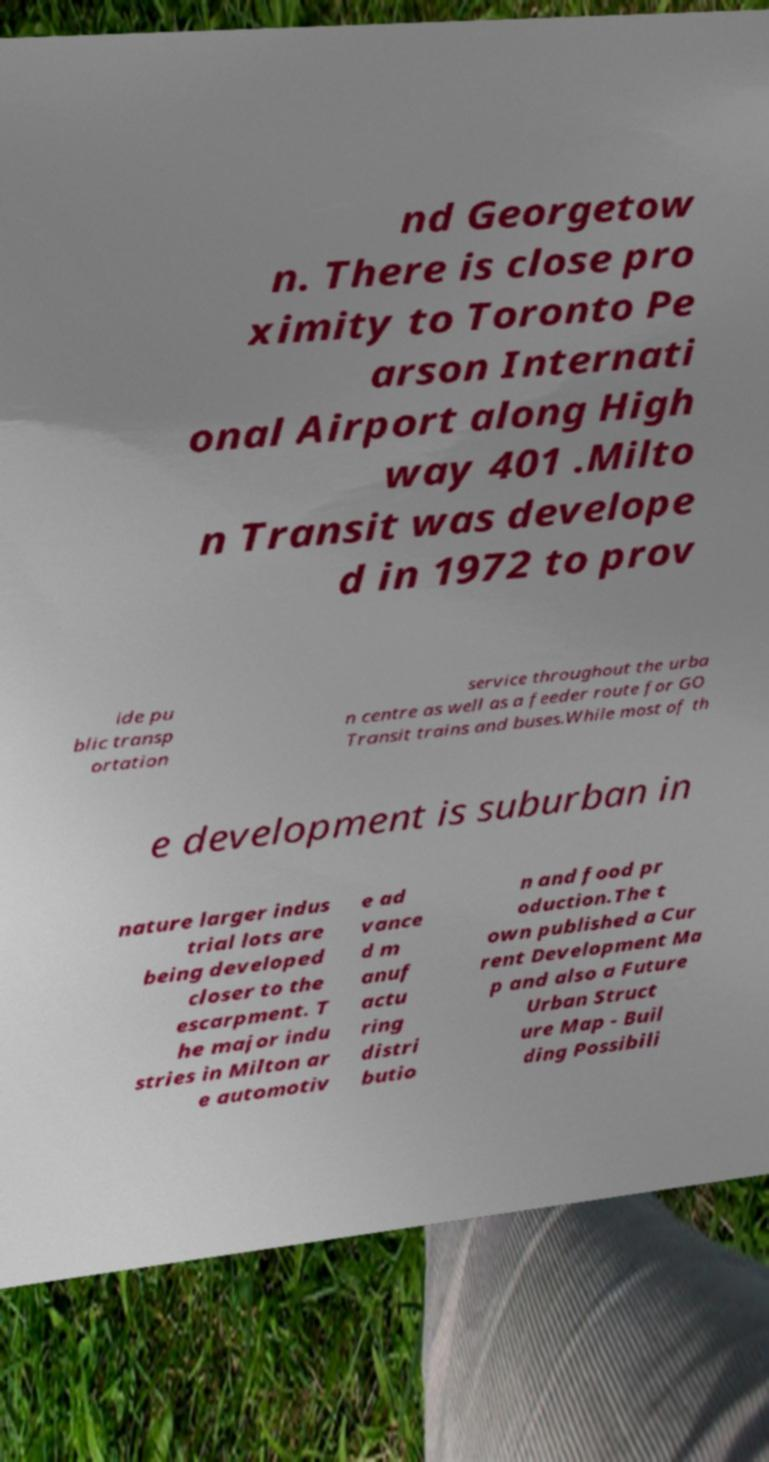Can you accurately transcribe the text from the provided image for me? nd Georgetow n. There is close pro ximity to Toronto Pe arson Internati onal Airport along High way 401 .Milto n Transit was develope d in 1972 to prov ide pu blic transp ortation service throughout the urba n centre as well as a feeder route for GO Transit trains and buses.While most of th e development is suburban in nature larger indus trial lots are being developed closer to the escarpment. T he major indu stries in Milton ar e automotiv e ad vance d m anuf actu ring distri butio n and food pr oduction.The t own published a Cur rent Development Ma p and also a Future Urban Struct ure Map - Buil ding Possibili 